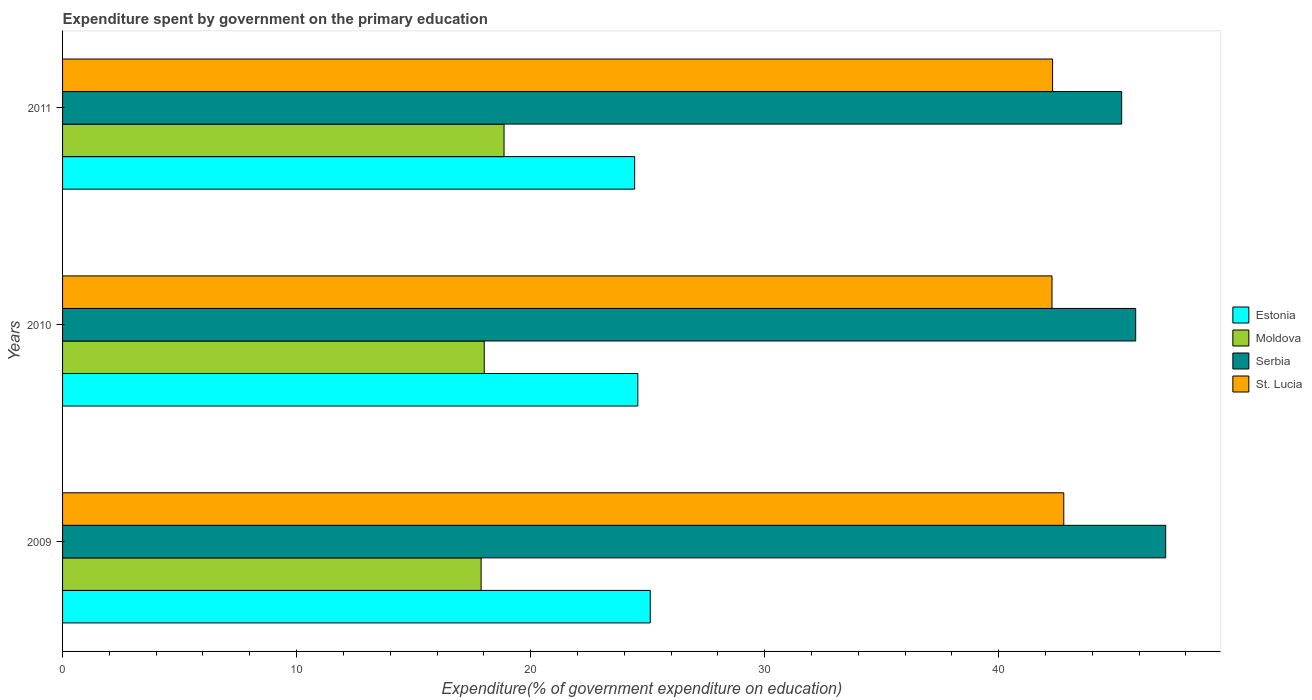How many different coloured bars are there?
Provide a short and direct response. 4. Are the number of bars on each tick of the Y-axis equal?
Provide a succinct answer. Yes. How many bars are there on the 2nd tick from the top?
Provide a succinct answer. 4. How many bars are there on the 2nd tick from the bottom?
Your response must be concise. 4. What is the label of the 2nd group of bars from the top?
Offer a terse response. 2010. What is the expenditure spent by government on the primary education in St. Lucia in 2009?
Provide a short and direct response. 42.78. Across all years, what is the maximum expenditure spent by government on the primary education in Estonia?
Keep it short and to the point. 25.11. Across all years, what is the minimum expenditure spent by government on the primary education in Moldova?
Provide a succinct answer. 17.89. What is the total expenditure spent by government on the primary education in Estonia in the graph?
Offer a terse response. 74.14. What is the difference between the expenditure spent by government on the primary education in Estonia in 2009 and that in 2011?
Ensure brevity in your answer.  0.67. What is the difference between the expenditure spent by government on the primary education in St. Lucia in 2010 and the expenditure spent by government on the primary education in Estonia in 2009?
Provide a succinct answer. 17.17. What is the average expenditure spent by government on the primary education in Moldova per year?
Ensure brevity in your answer.  18.26. In the year 2009, what is the difference between the expenditure spent by government on the primary education in Moldova and expenditure spent by government on the primary education in Serbia?
Your answer should be very brief. -29.25. In how many years, is the expenditure spent by government on the primary education in Estonia greater than 22 %?
Provide a short and direct response. 3. What is the ratio of the expenditure spent by government on the primary education in Estonia in 2009 to that in 2010?
Offer a very short reply. 1.02. Is the difference between the expenditure spent by government on the primary education in Moldova in 2010 and 2011 greater than the difference between the expenditure spent by government on the primary education in Serbia in 2010 and 2011?
Your answer should be very brief. No. What is the difference between the highest and the second highest expenditure spent by government on the primary education in Moldova?
Make the answer very short. 0.85. What is the difference between the highest and the lowest expenditure spent by government on the primary education in Estonia?
Make the answer very short. 0.67. Is it the case that in every year, the sum of the expenditure spent by government on the primary education in St. Lucia and expenditure spent by government on the primary education in Estonia is greater than the sum of expenditure spent by government on the primary education in Moldova and expenditure spent by government on the primary education in Serbia?
Give a very brief answer. No. What does the 2nd bar from the top in 2010 represents?
Offer a very short reply. Serbia. What does the 1st bar from the bottom in 2010 represents?
Keep it short and to the point. Estonia. How many years are there in the graph?
Offer a very short reply. 3. Does the graph contain any zero values?
Ensure brevity in your answer.  No. Does the graph contain grids?
Your answer should be very brief. No. How many legend labels are there?
Your answer should be very brief. 4. How are the legend labels stacked?
Ensure brevity in your answer.  Vertical. What is the title of the graph?
Ensure brevity in your answer.  Expenditure spent by government on the primary education. What is the label or title of the X-axis?
Your answer should be very brief. Expenditure(% of government expenditure on education). What is the Expenditure(% of government expenditure on education) of Estonia in 2009?
Give a very brief answer. 25.11. What is the Expenditure(% of government expenditure on education) in Moldova in 2009?
Ensure brevity in your answer.  17.89. What is the Expenditure(% of government expenditure on education) in Serbia in 2009?
Offer a very short reply. 47.14. What is the Expenditure(% of government expenditure on education) of St. Lucia in 2009?
Offer a very short reply. 42.78. What is the Expenditure(% of government expenditure on education) in Estonia in 2010?
Your response must be concise. 24.58. What is the Expenditure(% of government expenditure on education) of Moldova in 2010?
Offer a very short reply. 18.02. What is the Expenditure(% of government expenditure on education) in Serbia in 2010?
Make the answer very short. 45.86. What is the Expenditure(% of government expenditure on education) in St. Lucia in 2010?
Provide a short and direct response. 42.28. What is the Expenditure(% of government expenditure on education) of Estonia in 2011?
Ensure brevity in your answer.  24.45. What is the Expenditure(% of government expenditure on education) of Moldova in 2011?
Ensure brevity in your answer.  18.87. What is the Expenditure(% of government expenditure on education) of Serbia in 2011?
Provide a succinct answer. 45.26. What is the Expenditure(% of government expenditure on education) of St. Lucia in 2011?
Make the answer very short. 42.3. Across all years, what is the maximum Expenditure(% of government expenditure on education) in Estonia?
Offer a terse response. 25.11. Across all years, what is the maximum Expenditure(% of government expenditure on education) in Moldova?
Make the answer very short. 18.87. Across all years, what is the maximum Expenditure(% of government expenditure on education) in Serbia?
Offer a very short reply. 47.14. Across all years, what is the maximum Expenditure(% of government expenditure on education) of St. Lucia?
Your response must be concise. 42.78. Across all years, what is the minimum Expenditure(% of government expenditure on education) in Estonia?
Offer a very short reply. 24.45. Across all years, what is the minimum Expenditure(% of government expenditure on education) of Moldova?
Your answer should be very brief. 17.89. Across all years, what is the minimum Expenditure(% of government expenditure on education) in Serbia?
Give a very brief answer. 45.26. Across all years, what is the minimum Expenditure(% of government expenditure on education) of St. Lucia?
Offer a terse response. 42.28. What is the total Expenditure(% of government expenditure on education) of Estonia in the graph?
Provide a succinct answer. 74.14. What is the total Expenditure(% of government expenditure on education) in Moldova in the graph?
Keep it short and to the point. 54.77. What is the total Expenditure(% of government expenditure on education) in Serbia in the graph?
Your answer should be very brief. 138.25. What is the total Expenditure(% of government expenditure on education) of St. Lucia in the graph?
Give a very brief answer. 127.37. What is the difference between the Expenditure(% of government expenditure on education) in Estonia in 2009 and that in 2010?
Your response must be concise. 0.53. What is the difference between the Expenditure(% of government expenditure on education) in Moldova in 2009 and that in 2010?
Ensure brevity in your answer.  -0.13. What is the difference between the Expenditure(% of government expenditure on education) of Serbia in 2009 and that in 2010?
Your response must be concise. 1.28. What is the difference between the Expenditure(% of government expenditure on education) of St. Lucia in 2009 and that in 2010?
Offer a very short reply. 0.5. What is the difference between the Expenditure(% of government expenditure on education) of Estonia in 2009 and that in 2011?
Provide a succinct answer. 0.67. What is the difference between the Expenditure(% of government expenditure on education) in Moldova in 2009 and that in 2011?
Offer a very short reply. -0.98. What is the difference between the Expenditure(% of government expenditure on education) in Serbia in 2009 and that in 2011?
Offer a very short reply. 1.88. What is the difference between the Expenditure(% of government expenditure on education) of St. Lucia in 2009 and that in 2011?
Offer a very short reply. 0.48. What is the difference between the Expenditure(% of government expenditure on education) in Estonia in 2010 and that in 2011?
Provide a succinct answer. 0.14. What is the difference between the Expenditure(% of government expenditure on education) in Moldova in 2010 and that in 2011?
Provide a short and direct response. -0.85. What is the difference between the Expenditure(% of government expenditure on education) in Serbia in 2010 and that in 2011?
Provide a short and direct response. 0.6. What is the difference between the Expenditure(% of government expenditure on education) in St. Lucia in 2010 and that in 2011?
Offer a very short reply. -0.03. What is the difference between the Expenditure(% of government expenditure on education) in Estonia in 2009 and the Expenditure(% of government expenditure on education) in Moldova in 2010?
Provide a short and direct response. 7.09. What is the difference between the Expenditure(% of government expenditure on education) in Estonia in 2009 and the Expenditure(% of government expenditure on education) in Serbia in 2010?
Provide a short and direct response. -20.74. What is the difference between the Expenditure(% of government expenditure on education) of Estonia in 2009 and the Expenditure(% of government expenditure on education) of St. Lucia in 2010?
Give a very brief answer. -17.17. What is the difference between the Expenditure(% of government expenditure on education) of Moldova in 2009 and the Expenditure(% of government expenditure on education) of Serbia in 2010?
Offer a very short reply. -27.97. What is the difference between the Expenditure(% of government expenditure on education) in Moldova in 2009 and the Expenditure(% of government expenditure on education) in St. Lucia in 2010?
Your answer should be very brief. -24.39. What is the difference between the Expenditure(% of government expenditure on education) of Serbia in 2009 and the Expenditure(% of government expenditure on education) of St. Lucia in 2010?
Offer a very short reply. 4.86. What is the difference between the Expenditure(% of government expenditure on education) of Estonia in 2009 and the Expenditure(% of government expenditure on education) of Moldova in 2011?
Provide a succinct answer. 6.25. What is the difference between the Expenditure(% of government expenditure on education) in Estonia in 2009 and the Expenditure(% of government expenditure on education) in Serbia in 2011?
Offer a very short reply. -20.14. What is the difference between the Expenditure(% of government expenditure on education) of Estonia in 2009 and the Expenditure(% of government expenditure on education) of St. Lucia in 2011?
Your answer should be very brief. -17.19. What is the difference between the Expenditure(% of government expenditure on education) in Moldova in 2009 and the Expenditure(% of government expenditure on education) in Serbia in 2011?
Keep it short and to the point. -27.37. What is the difference between the Expenditure(% of government expenditure on education) in Moldova in 2009 and the Expenditure(% of government expenditure on education) in St. Lucia in 2011?
Keep it short and to the point. -24.42. What is the difference between the Expenditure(% of government expenditure on education) of Serbia in 2009 and the Expenditure(% of government expenditure on education) of St. Lucia in 2011?
Offer a very short reply. 4.83. What is the difference between the Expenditure(% of government expenditure on education) in Estonia in 2010 and the Expenditure(% of government expenditure on education) in Moldova in 2011?
Your answer should be compact. 5.72. What is the difference between the Expenditure(% of government expenditure on education) in Estonia in 2010 and the Expenditure(% of government expenditure on education) in Serbia in 2011?
Your answer should be very brief. -20.67. What is the difference between the Expenditure(% of government expenditure on education) in Estonia in 2010 and the Expenditure(% of government expenditure on education) in St. Lucia in 2011?
Make the answer very short. -17.72. What is the difference between the Expenditure(% of government expenditure on education) in Moldova in 2010 and the Expenditure(% of government expenditure on education) in Serbia in 2011?
Your response must be concise. -27.24. What is the difference between the Expenditure(% of government expenditure on education) of Moldova in 2010 and the Expenditure(% of government expenditure on education) of St. Lucia in 2011?
Your answer should be compact. -24.29. What is the difference between the Expenditure(% of government expenditure on education) in Serbia in 2010 and the Expenditure(% of government expenditure on education) in St. Lucia in 2011?
Offer a terse response. 3.55. What is the average Expenditure(% of government expenditure on education) in Estonia per year?
Keep it short and to the point. 24.71. What is the average Expenditure(% of government expenditure on education) in Moldova per year?
Your answer should be compact. 18.26. What is the average Expenditure(% of government expenditure on education) in Serbia per year?
Your answer should be compact. 46.08. What is the average Expenditure(% of government expenditure on education) of St. Lucia per year?
Provide a succinct answer. 42.46. In the year 2009, what is the difference between the Expenditure(% of government expenditure on education) in Estonia and Expenditure(% of government expenditure on education) in Moldova?
Your answer should be compact. 7.23. In the year 2009, what is the difference between the Expenditure(% of government expenditure on education) in Estonia and Expenditure(% of government expenditure on education) in Serbia?
Your answer should be very brief. -22.02. In the year 2009, what is the difference between the Expenditure(% of government expenditure on education) in Estonia and Expenditure(% of government expenditure on education) in St. Lucia?
Ensure brevity in your answer.  -17.67. In the year 2009, what is the difference between the Expenditure(% of government expenditure on education) of Moldova and Expenditure(% of government expenditure on education) of Serbia?
Ensure brevity in your answer.  -29.25. In the year 2009, what is the difference between the Expenditure(% of government expenditure on education) of Moldova and Expenditure(% of government expenditure on education) of St. Lucia?
Provide a short and direct response. -24.9. In the year 2009, what is the difference between the Expenditure(% of government expenditure on education) of Serbia and Expenditure(% of government expenditure on education) of St. Lucia?
Keep it short and to the point. 4.35. In the year 2010, what is the difference between the Expenditure(% of government expenditure on education) of Estonia and Expenditure(% of government expenditure on education) of Moldova?
Ensure brevity in your answer.  6.56. In the year 2010, what is the difference between the Expenditure(% of government expenditure on education) in Estonia and Expenditure(% of government expenditure on education) in Serbia?
Keep it short and to the point. -21.27. In the year 2010, what is the difference between the Expenditure(% of government expenditure on education) in Estonia and Expenditure(% of government expenditure on education) in St. Lucia?
Your response must be concise. -17.7. In the year 2010, what is the difference between the Expenditure(% of government expenditure on education) in Moldova and Expenditure(% of government expenditure on education) in Serbia?
Ensure brevity in your answer.  -27.84. In the year 2010, what is the difference between the Expenditure(% of government expenditure on education) of Moldova and Expenditure(% of government expenditure on education) of St. Lucia?
Keep it short and to the point. -24.26. In the year 2010, what is the difference between the Expenditure(% of government expenditure on education) of Serbia and Expenditure(% of government expenditure on education) of St. Lucia?
Give a very brief answer. 3.58. In the year 2011, what is the difference between the Expenditure(% of government expenditure on education) of Estonia and Expenditure(% of government expenditure on education) of Moldova?
Provide a succinct answer. 5.58. In the year 2011, what is the difference between the Expenditure(% of government expenditure on education) in Estonia and Expenditure(% of government expenditure on education) in Serbia?
Your answer should be compact. -20.81. In the year 2011, what is the difference between the Expenditure(% of government expenditure on education) in Estonia and Expenditure(% of government expenditure on education) in St. Lucia?
Your response must be concise. -17.86. In the year 2011, what is the difference between the Expenditure(% of government expenditure on education) of Moldova and Expenditure(% of government expenditure on education) of Serbia?
Your answer should be compact. -26.39. In the year 2011, what is the difference between the Expenditure(% of government expenditure on education) of Moldova and Expenditure(% of government expenditure on education) of St. Lucia?
Give a very brief answer. -23.44. In the year 2011, what is the difference between the Expenditure(% of government expenditure on education) of Serbia and Expenditure(% of government expenditure on education) of St. Lucia?
Your answer should be compact. 2.95. What is the ratio of the Expenditure(% of government expenditure on education) of Estonia in 2009 to that in 2010?
Offer a terse response. 1.02. What is the ratio of the Expenditure(% of government expenditure on education) of Moldova in 2009 to that in 2010?
Keep it short and to the point. 0.99. What is the ratio of the Expenditure(% of government expenditure on education) in Serbia in 2009 to that in 2010?
Your response must be concise. 1.03. What is the ratio of the Expenditure(% of government expenditure on education) of St. Lucia in 2009 to that in 2010?
Offer a terse response. 1.01. What is the ratio of the Expenditure(% of government expenditure on education) of Estonia in 2009 to that in 2011?
Your answer should be compact. 1.03. What is the ratio of the Expenditure(% of government expenditure on education) of Moldova in 2009 to that in 2011?
Keep it short and to the point. 0.95. What is the ratio of the Expenditure(% of government expenditure on education) in Serbia in 2009 to that in 2011?
Offer a very short reply. 1.04. What is the ratio of the Expenditure(% of government expenditure on education) of St. Lucia in 2009 to that in 2011?
Give a very brief answer. 1.01. What is the ratio of the Expenditure(% of government expenditure on education) in Estonia in 2010 to that in 2011?
Provide a short and direct response. 1.01. What is the ratio of the Expenditure(% of government expenditure on education) of Moldova in 2010 to that in 2011?
Your answer should be very brief. 0.96. What is the ratio of the Expenditure(% of government expenditure on education) of Serbia in 2010 to that in 2011?
Offer a very short reply. 1.01. What is the difference between the highest and the second highest Expenditure(% of government expenditure on education) of Estonia?
Make the answer very short. 0.53. What is the difference between the highest and the second highest Expenditure(% of government expenditure on education) of Moldova?
Your response must be concise. 0.85. What is the difference between the highest and the second highest Expenditure(% of government expenditure on education) of Serbia?
Ensure brevity in your answer.  1.28. What is the difference between the highest and the second highest Expenditure(% of government expenditure on education) in St. Lucia?
Give a very brief answer. 0.48. What is the difference between the highest and the lowest Expenditure(% of government expenditure on education) in Estonia?
Ensure brevity in your answer.  0.67. What is the difference between the highest and the lowest Expenditure(% of government expenditure on education) in Moldova?
Your response must be concise. 0.98. What is the difference between the highest and the lowest Expenditure(% of government expenditure on education) in Serbia?
Offer a terse response. 1.88. What is the difference between the highest and the lowest Expenditure(% of government expenditure on education) of St. Lucia?
Your answer should be compact. 0.5. 